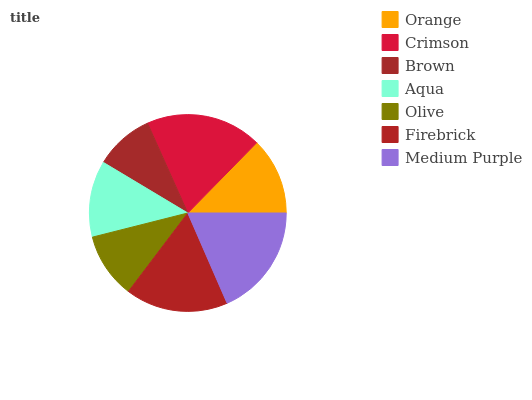Is Brown the minimum?
Answer yes or no. Yes. Is Crimson the maximum?
Answer yes or no. Yes. Is Crimson the minimum?
Answer yes or no. No. Is Brown the maximum?
Answer yes or no. No. Is Crimson greater than Brown?
Answer yes or no. Yes. Is Brown less than Crimson?
Answer yes or no. Yes. Is Brown greater than Crimson?
Answer yes or no. No. Is Crimson less than Brown?
Answer yes or no. No. Is Orange the high median?
Answer yes or no. Yes. Is Orange the low median?
Answer yes or no. Yes. Is Aqua the high median?
Answer yes or no. No. Is Aqua the low median?
Answer yes or no. No. 